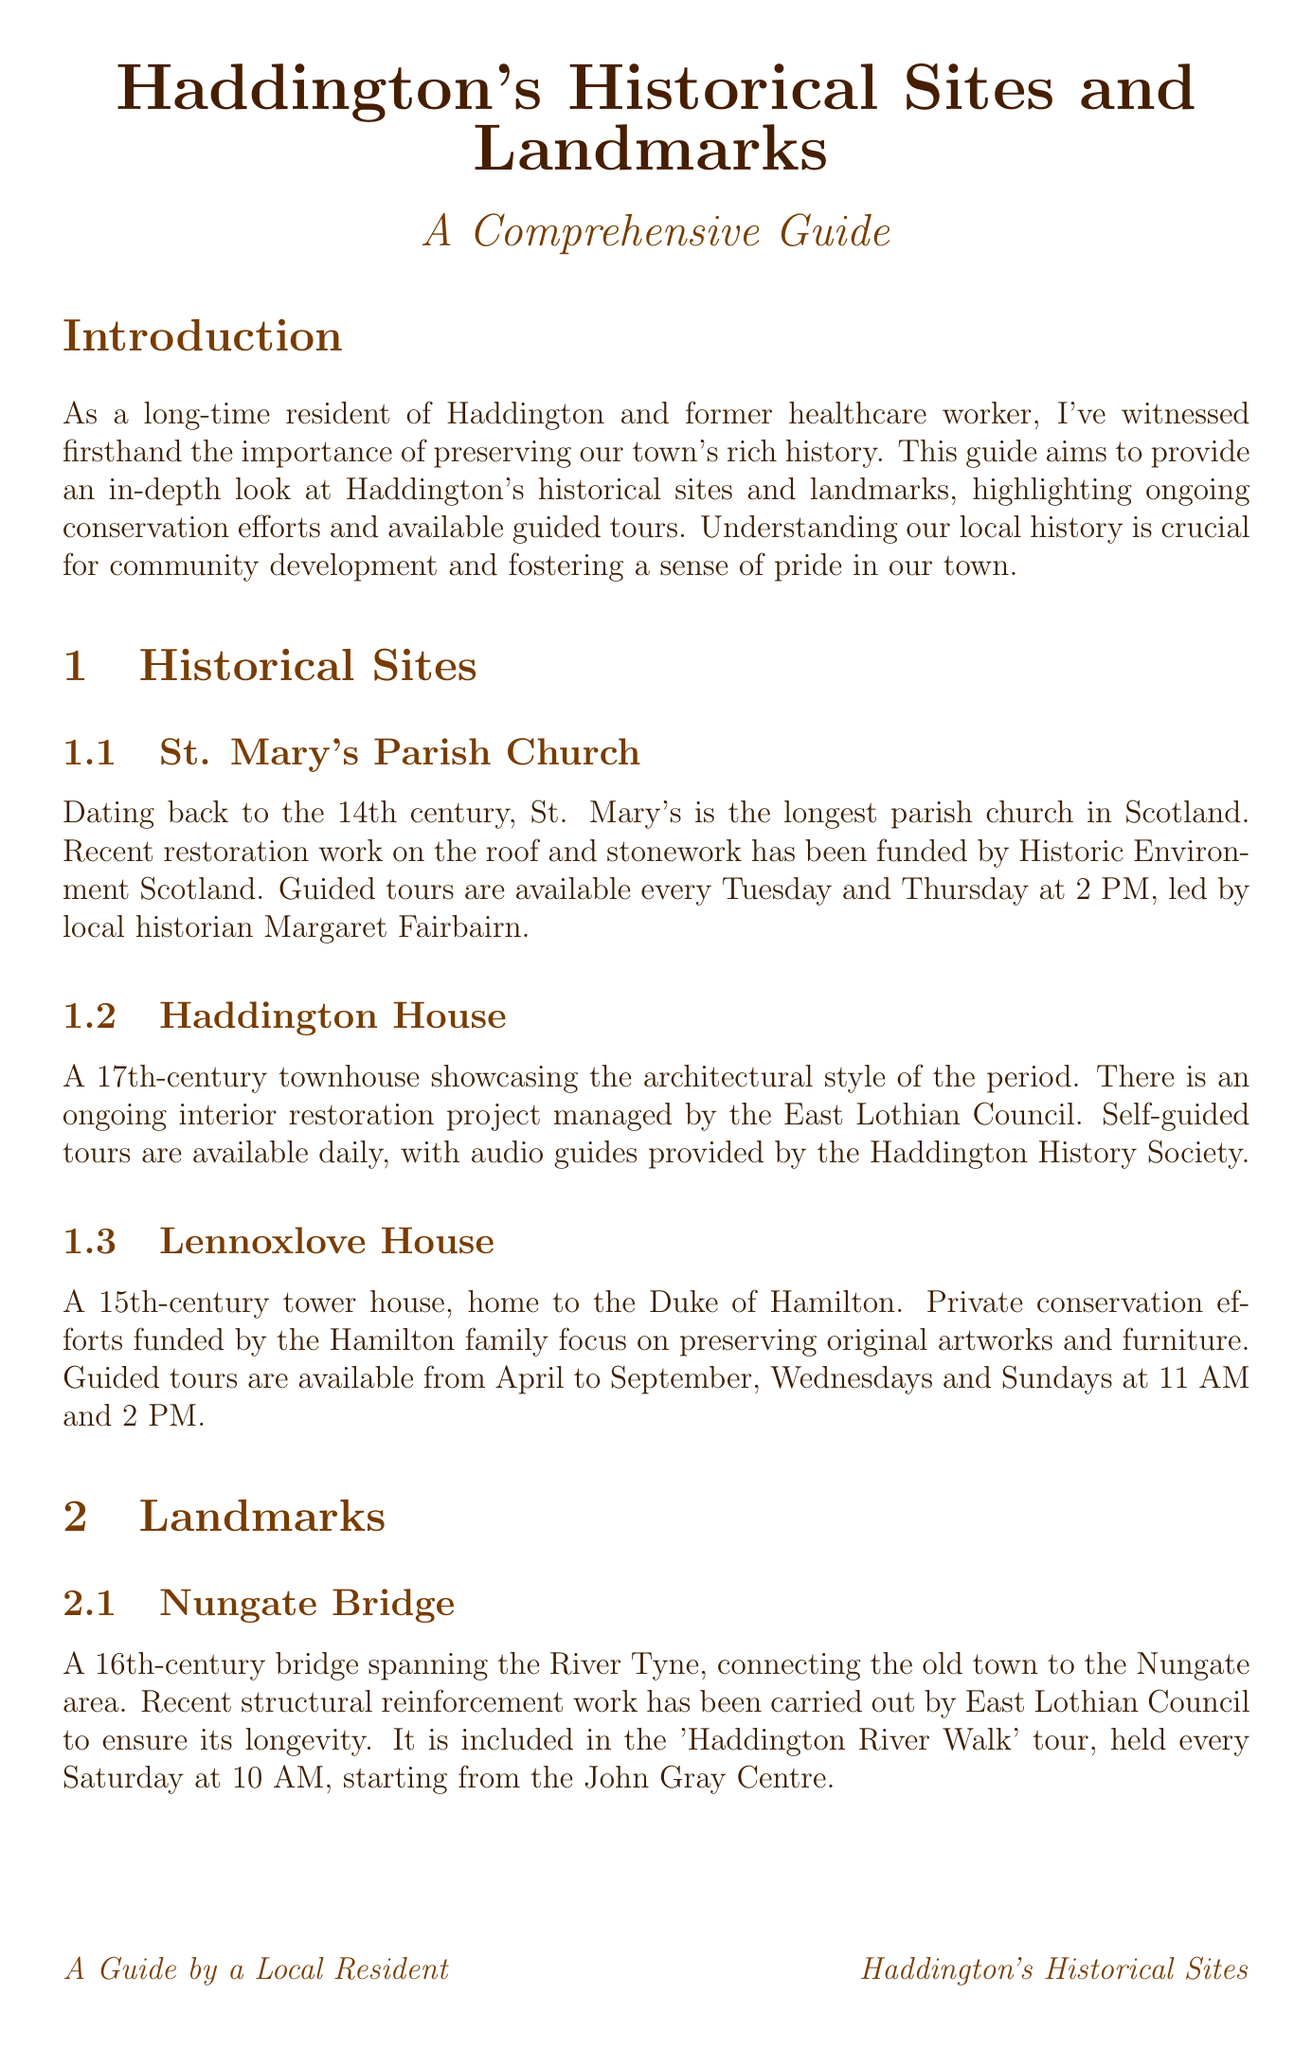What is the title of the guide? The title is clearly stated at the beginning of the document, which is "Haddington's Historical Sites and Landmarks: A Comprehensive Guide."
Answer: Haddington's Historical Sites and Landmarks: A Comprehensive Guide Who funds the recent restoration work on St. Mary's Parish Church? The document mentions that the restoration work is funded by Historic Environment Scotland.
Answer: Historic Environment Scotland What is the meeting point for the "Architectural Gems of Haddington" tour? The document specifies that the meeting point for this tour is the Haddington Town House.
Answer: Haddington Town House How many guided tours per week does Lennoxlove House offer? The document states that guided tours are available on Wednesdays and Sundays, totaling four tours a week.
Answer: Four Which organization organizes volunteer clean-up events? The Haddington Heritage Trust is identified in the document as organizing volunteer clean-up events.
Answer: Haddington Heritage Trust What is the price for the "Haddington Through the Ages" tour? The document provides the price for this tour as £15 per person.
Answer: £15 per person What month do guided tours at Haddington Town House occur? The document indicates that guided tours are held monthly on the first Monday of each month.
Answer: Monthly What is the main goal of the Haddington Heritage Trust? The document describes the main goal of the Haddington Heritage Trust as preserving Haddington's historical sites.
Answer: Preserving Haddington's historical sites 